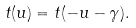<formula> <loc_0><loc_0><loc_500><loc_500>t ( u ) = t ( - u - \gamma ) .</formula> 